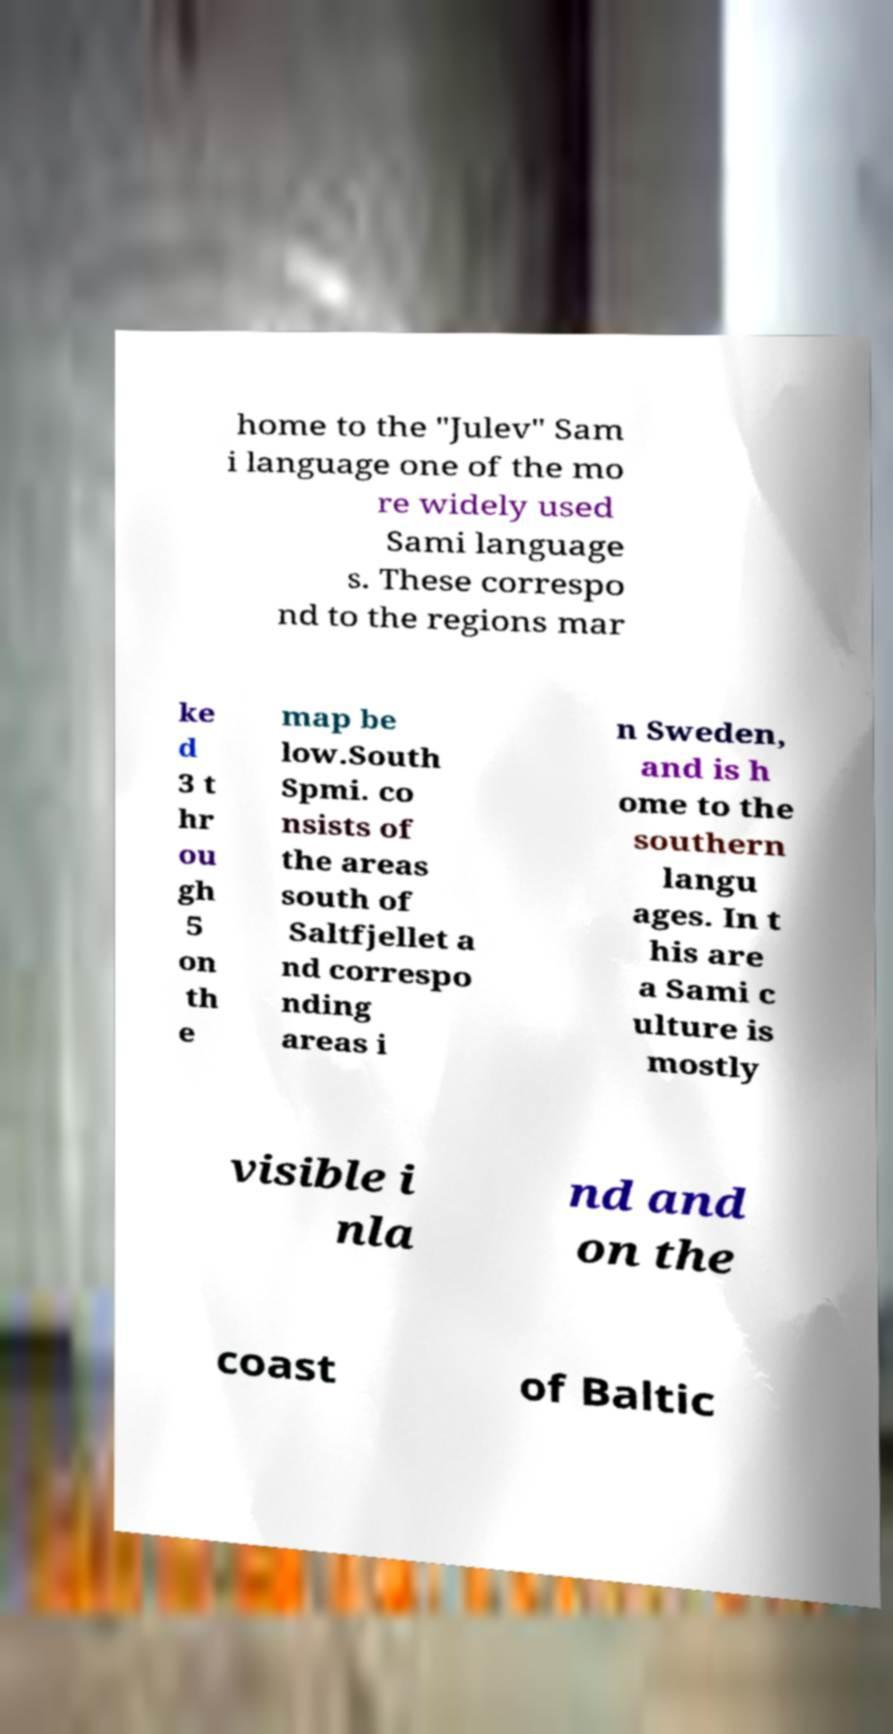Please identify and transcribe the text found in this image. home to the "Julev" Sam i language one of the mo re widely used Sami language s. These correspo nd to the regions mar ke d 3 t hr ou gh 5 on th e map be low.South Spmi. co nsists of the areas south of Saltfjellet a nd correspo nding areas i n Sweden, and is h ome to the southern langu ages. In t his are a Sami c ulture is mostly visible i nla nd and on the coast of Baltic 